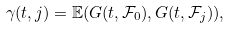<formula> <loc_0><loc_0><loc_500><loc_500>\gamma ( t , j ) = \mathbb { E } ( G ( t , \mathcal { F } _ { 0 } ) , G ( t , \mathcal { F } _ { j } ) ) ,</formula> 